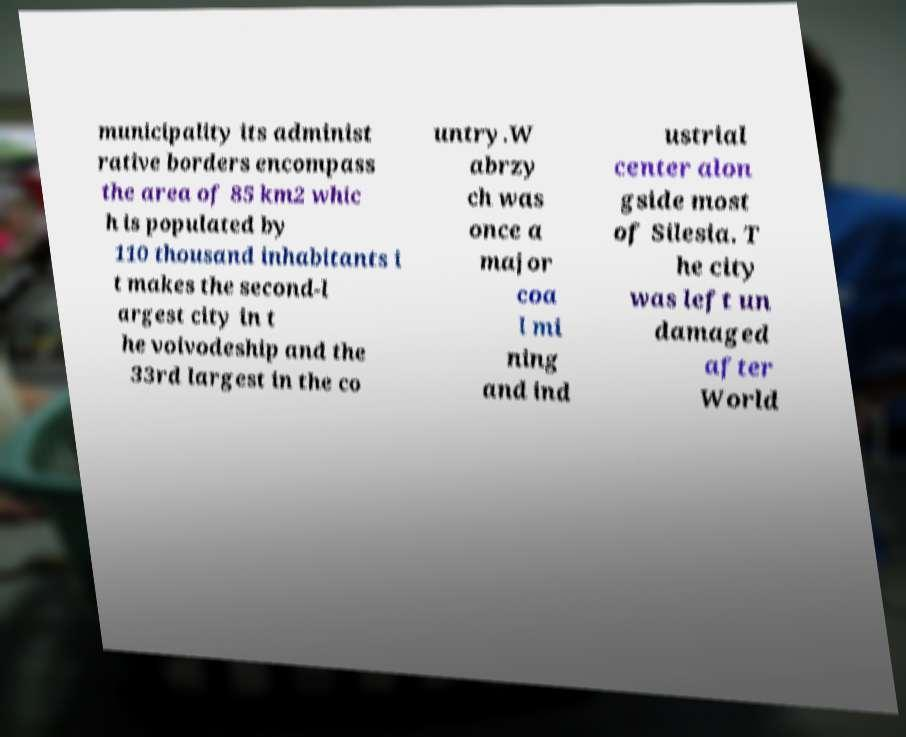Can you accurately transcribe the text from the provided image for me? municipality its administ rative borders encompass the area of 85 km2 whic h is populated by 110 thousand inhabitants i t makes the second-l argest city in t he voivodeship and the 33rd largest in the co untry.W abrzy ch was once a major coa l mi ning and ind ustrial center alon gside most of Silesia. T he city was left un damaged after World 